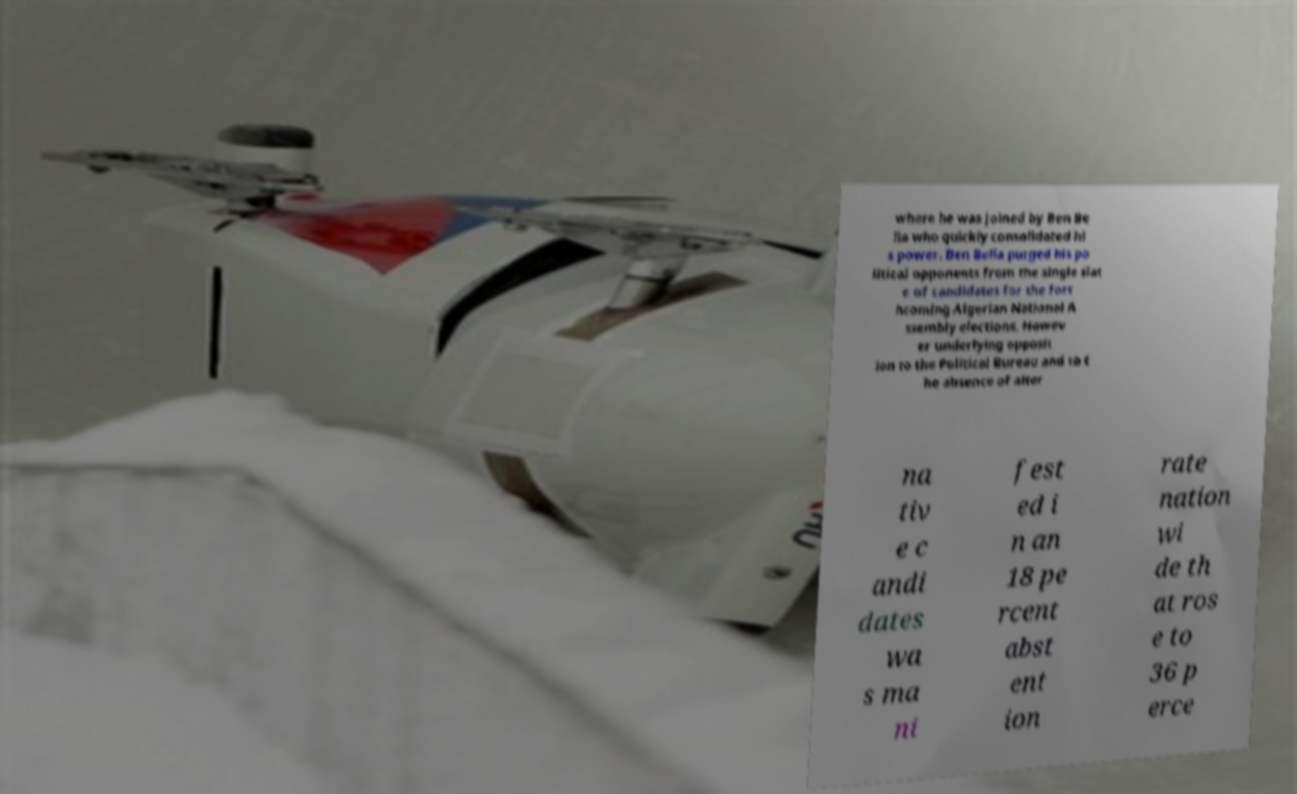Please read and relay the text visible in this image. What does it say? where he was joined by Ben Be lla who quickly consolidated hi s power. Ben Bella purged his po litical opponents from the single slat e of candidates for the fort hcoming Algerian National A ssembly elections. Howev er underlying opposit ion to the Political Bureau and to t he absence of alter na tiv e c andi dates wa s ma ni fest ed i n an 18 pe rcent abst ent ion rate nation wi de th at ros e to 36 p erce 